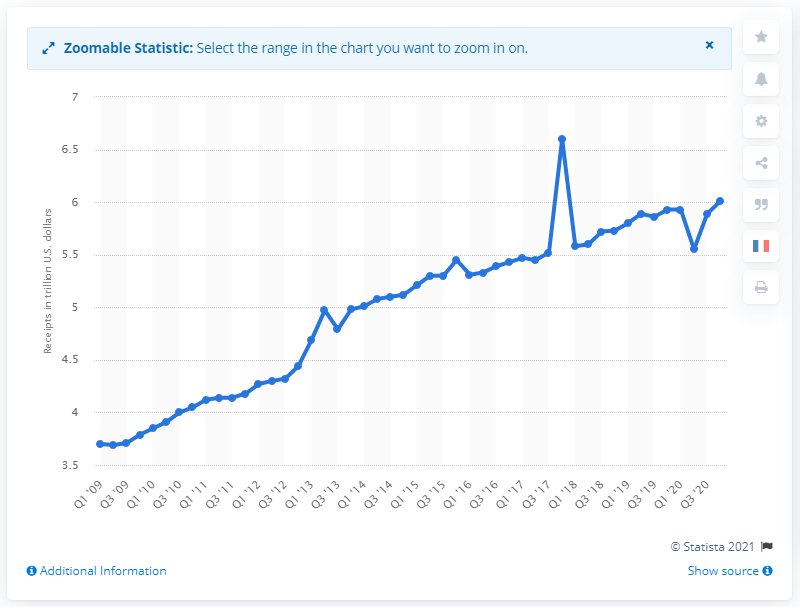Draw attention to some important aspects in this diagram. In the fourth quarter of 2020, the total annual receipts of the U.S. government were 6.01 trillion dollars. The total governmental receipts in the first quarter of 2009 was 3.71... 